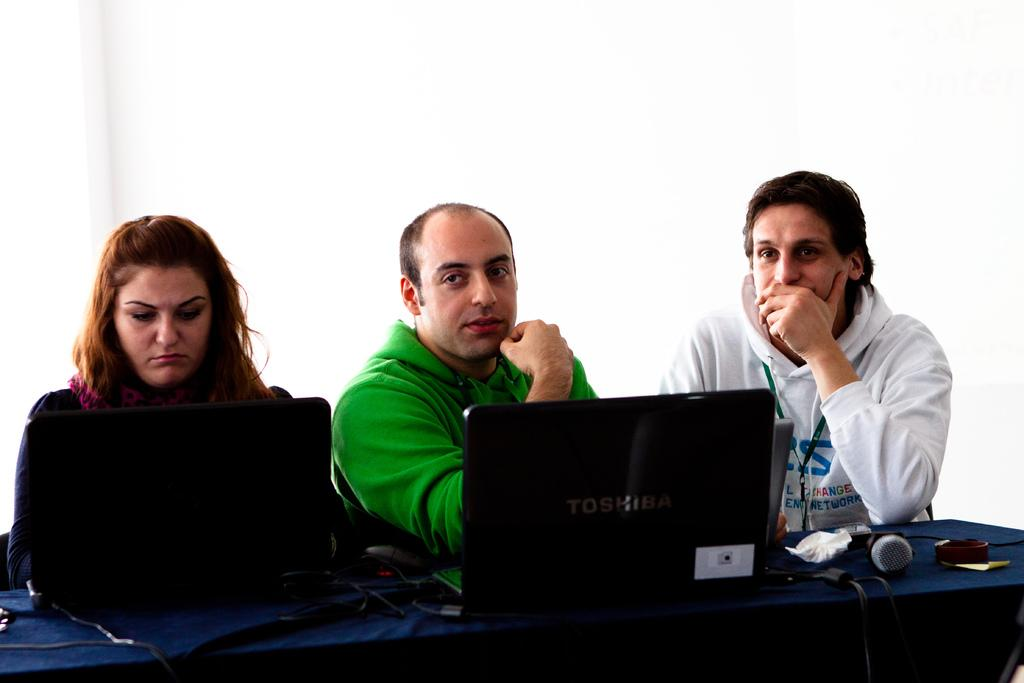What are the people in the image doing? The people in the image are seated on chairs. What objects can be seen on the table in the image? There are laptops, a microphone, and a watch on the table in the image. What is the color of the background in the image? The background of the image is white. Are there any deer visible in the image? No, there are no deer present in the image. What type of cemetery can be seen in the background of the image? There is no cemetery present in the image; the background is white. 